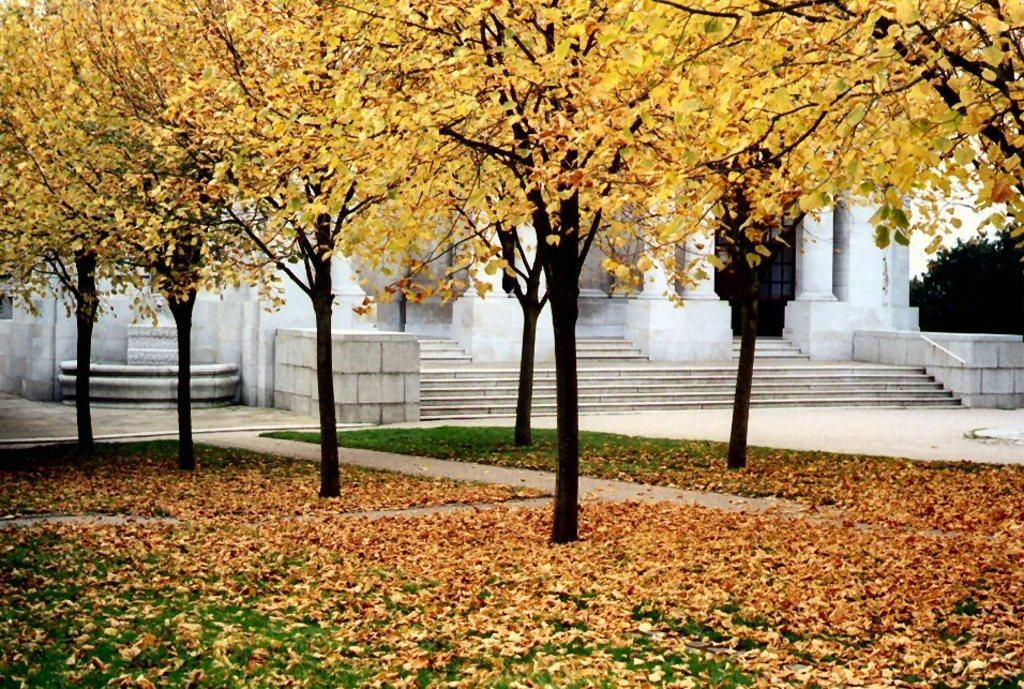What type of vegetation can be seen in the image? There are yellow leaves in the image. What is visible in the background of the image? There is a building in the background of the image. What color is the building? The building is white. What is the color of the sky in the image? The sky is white in the image. What type of minister is depicted in the image? There is no minister present in the image. Can you locate a map in the image? There is no map present in the image. 